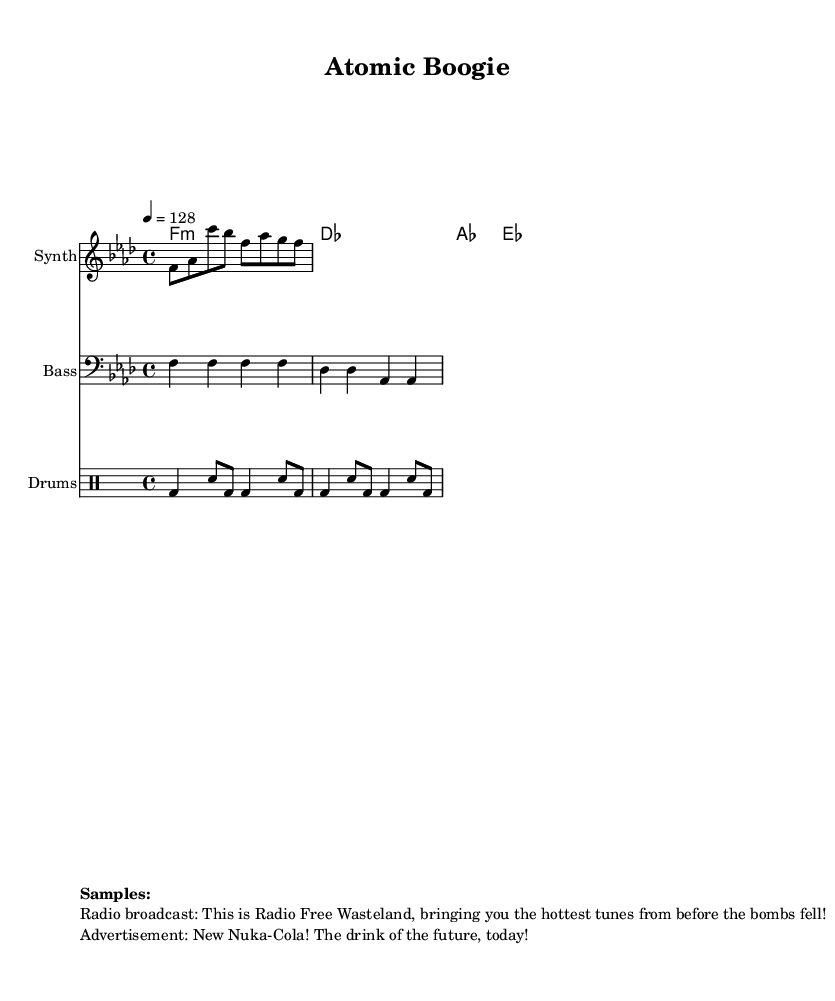What is the key signature of this music? The key signature is indicated at the beginning of the score where it shows a flat symbol. Since there is one flat (B-flat), the key signature corresponds to F minor.
Answer: F minor What is the time signature of this music? The time signature is located right after the key signature, displayed as a fraction. It shows 4 over 4, indicating that there are four beats in each measure.
Answer: 4/4 What is the tempo marking of this music? The tempo marking is located near the beginning of the music and indicates the speed at which the music should be played. It states "4 = 128," meaning there are 128 beats per minute.
Answer: 128 How many measures are in the melody section? The melody section is represented in the score; counting the notation reveals there are four measures total comprising the notes.
Answer: 4 What type of drum is primarily featured in this piece? The drum notation shows various symbols, and the notation begins with "bd" which stands for bass drum, indicating that it plays a vital role in the track.
Answer: Bass drum What is the main thematic inspiration evident in the samples used? The samples include texts from a hypothetical radio broadcast and advertisement that reflect a retro, 1950s audio style, aligned with the piece's overall aesthetic.
Answer: 1950s radio broadcasts 